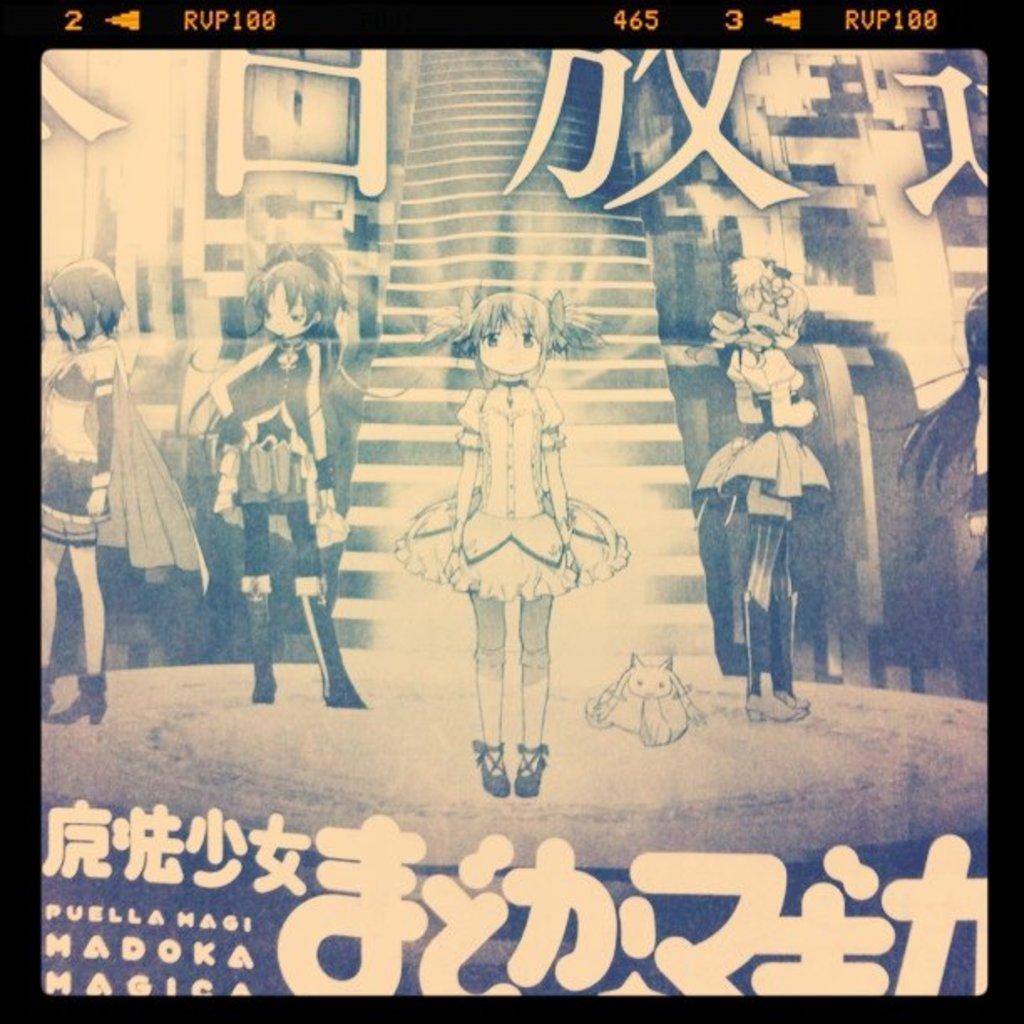Please provide a concise description of this image. In the image there are few anime characters standing, this is a black and white picture. 